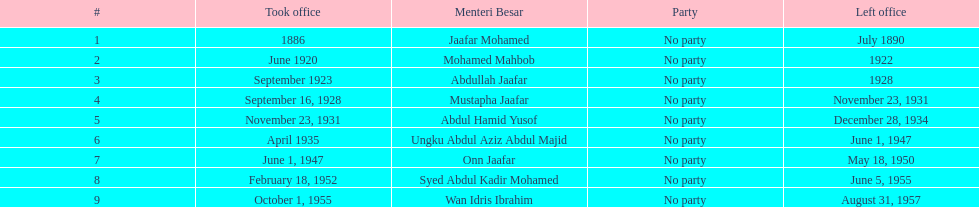When did jaafar mohamed take office? 1886. When did mohamed mahbob take office? June 1920. Who was in office no more than 4 years? Mohamed Mahbob. 